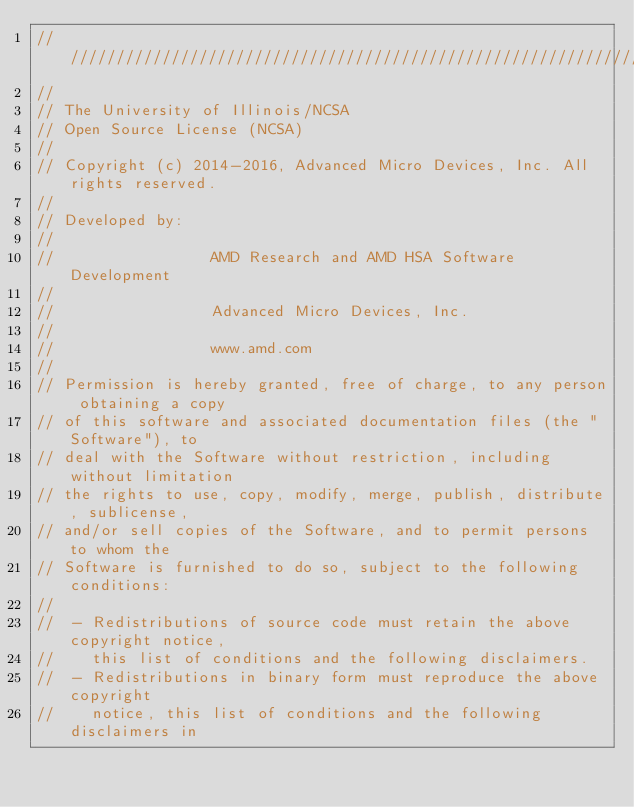<code> <loc_0><loc_0><loc_500><loc_500><_C++_>////////////////////////////////////////////////////////////////////////////////
//
// The University of Illinois/NCSA
// Open Source License (NCSA)
//
// Copyright (c) 2014-2016, Advanced Micro Devices, Inc. All rights reserved.
//
// Developed by:
//
//                 AMD Research and AMD HSA Software Development
//
//                 Advanced Micro Devices, Inc.
//
//                 www.amd.com
//
// Permission is hereby granted, free of charge, to any person obtaining a copy
// of this software and associated documentation files (the "Software"), to
// deal with the Software without restriction, including without limitation
// the rights to use, copy, modify, merge, publish, distribute, sublicense,
// and/or sell copies of the Software, and to permit persons to whom the
// Software is furnished to do so, subject to the following conditions:
//
//  - Redistributions of source code must retain the above copyright notice,
//    this list of conditions and the following disclaimers.
//  - Redistributions in binary form must reproduce the above copyright
//    notice, this list of conditions and the following disclaimers in</code> 